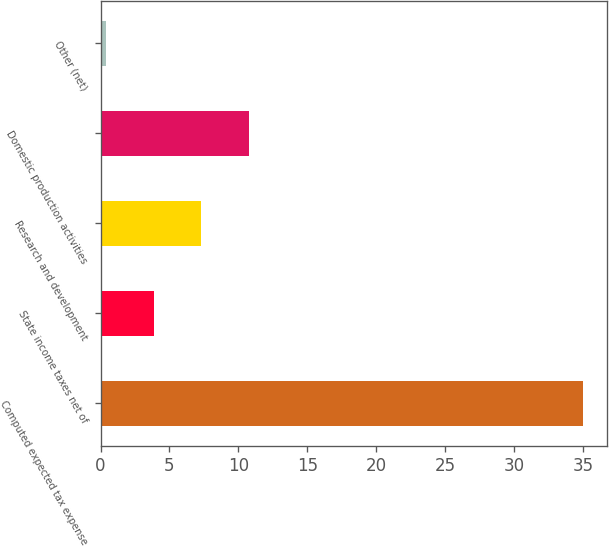Convert chart to OTSL. <chart><loc_0><loc_0><loc_500><loc_500><bar_chart><fcel>Computed expected tax expense<fcel>State income taxes net of<fcel>Research and development<fcel>Domestic production activities<fcel>Other (net)<nl><fcel>35<fcel>3.86<fcel>7.32<fcel>10.78<fcel>0.4<nl></chart> 